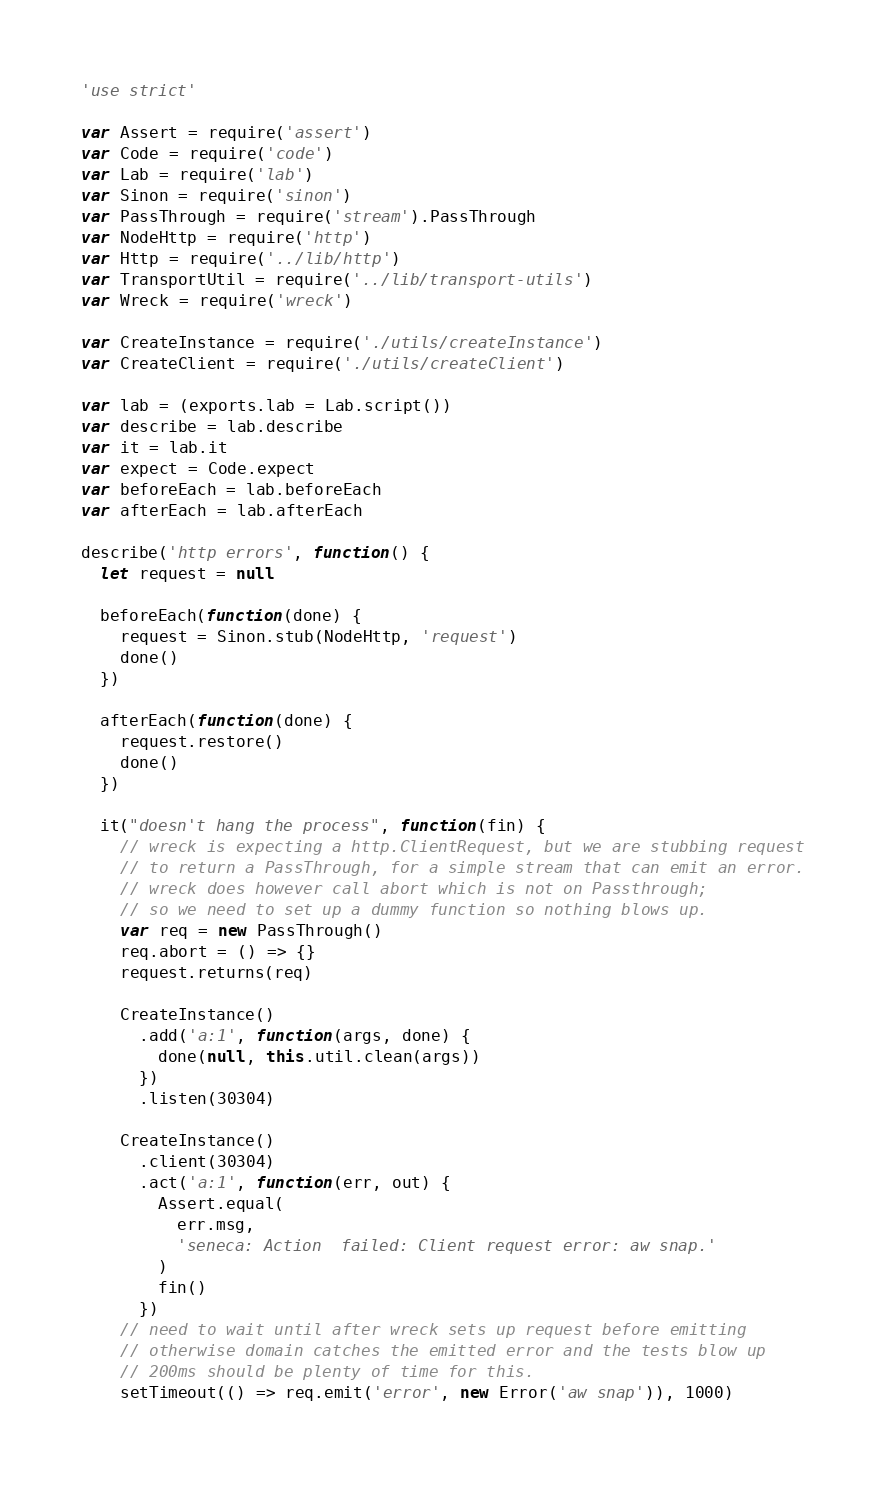Convert code to text. <code><loc_0><loc_0><loc_500><loc_500><_JavaScript_>'use strict'

var Assert = require('assert')
var Code = require('code')
var Lab = require('lab')
var Sinon = require('sinon')
var PassThrough = require('stream').PassThrough
var NodeHttp = require('http')
var Http = require('../lib/http')
var TransportUtil = require('../lib/transport-utils')
var Wreck = require('wreck')

var CreateInstance = require('./utils/createInstance')
var CreateClient = require('./utils/createClient')

var lab = (exports.lab = Lab.script())
var describe = lab.describe
var it = lab.it
var expect = Code.expect
var beforeEach = lab.beforeEach
var afterEach = lab.afterEach

describe('http errors', function() {
  let request = null

  beforeEach(function(done) {
    request = Sinon.stub(NodeHttp, 'request')
    done()
  })

  afterEach(function(done) {
    request.restore()
    done()
  })

  it("doesn't hang the process", function(fin) {
    // wreck is expecting a http.ClientRequest, but we are stubbing request
    // to return a PassThrough, for a simple stream that can emit an error.
    // wreck does however call abort which is not on Passthrough;
    // so we need to set up a dummy function so nothing blows up.
    var req = new PassThrough()
    req.abort = () => {}
    request.returns(req)

    CreateInstance()
      .add('a:1', function(args, done) {
        done(null, this.util.clean(args))
      })
      .listen(30304)

    CreateInstance()
      .client(30304)
      .act('a:1', function(err, out) {
        Assert.equal(
          err.msg,
          'seneca: Action  failed: Client request error: aw snap.'
        )
        fin()
      })
    // need to wait until after wreck sets up request before emitting
    // otherwise domain catches the emitted error and the tests blow up
    // 200ms should be plenty of time for this.
    setTimeout(() => req.emit('error', new Error('aw snap')), 1000)</code> 